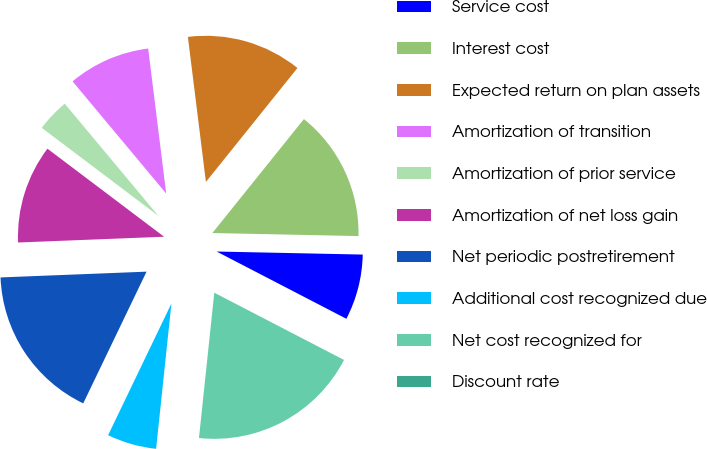<chart> <loc_0><loc_0><loc_500><loc_500><pie_chart><fcel>Service cost<fcel>Interest cost<fcel>Expected return on plan assets<fcel>Amortization of transition<fcel>Amortization of prior service<fcel>Amortization of net loss gain<fcel>Net periodic postretirement<fcel>Additional cost recognized due<fcel>Net cost recognized for<fcel>Discount rate<nl><fcel>7.28%<fcel>14.56%<fcel>12.74%<fcel>9.1%<fcel>3.64%<fcel>10.92%<fcel>17.24%<fcel>5.46%<fcel>19.06%<fcel>0.0%<nl></chart> 